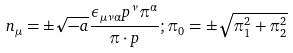Convert formula to latex. <formula><loc_0><loc_0><loc_500><loc_500>n _ { \mu } = \pm \sqrt { - a } \frac { \epsilon _ { \mu \nu \alpha } p ^ { \nu } \pi ^ { \alpha } } { \pi \cdot p } ; \pi _ { 0 } = \pm \sqrt { \pi _ { 1 } ^ { 2 } + \pi _ { 2 } ^ { 2 } }</formula> 